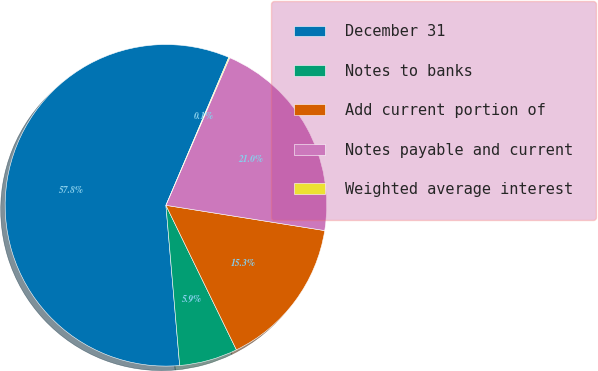Convert chart. <chart><loc_0><loc_0><loc_500><loc_500><pie_chart><fcel>December 31<fcel>Notes to banks<fcel>Add current portion of<fcel>Notes payable and current<fcel>Weighted average interest<nl><fcel>57.76%<fcel>5.86%<fcel>15.27%<fcel>21.03%<fcel>0.09%<nl></chart> 